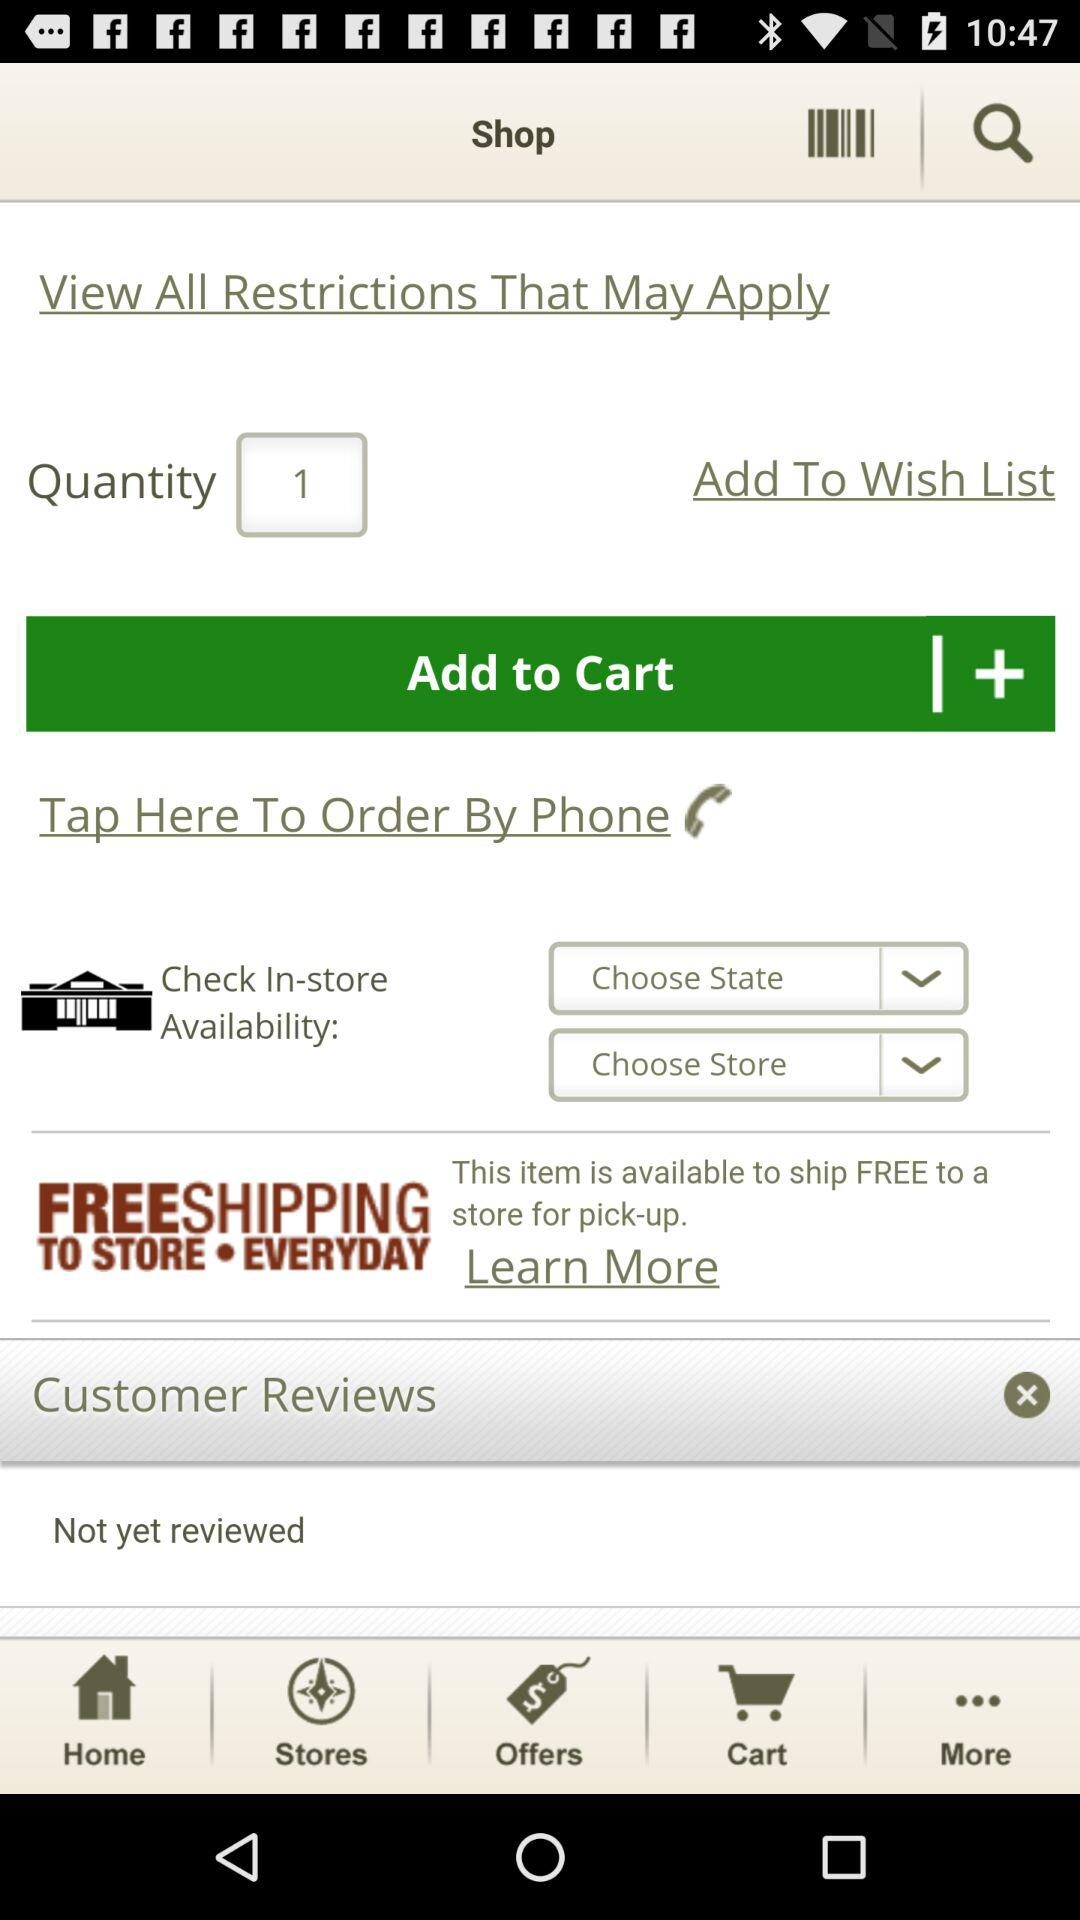Is the item available in store?
When the provided information is insufficient, respond with <no answer>. <no answer> 